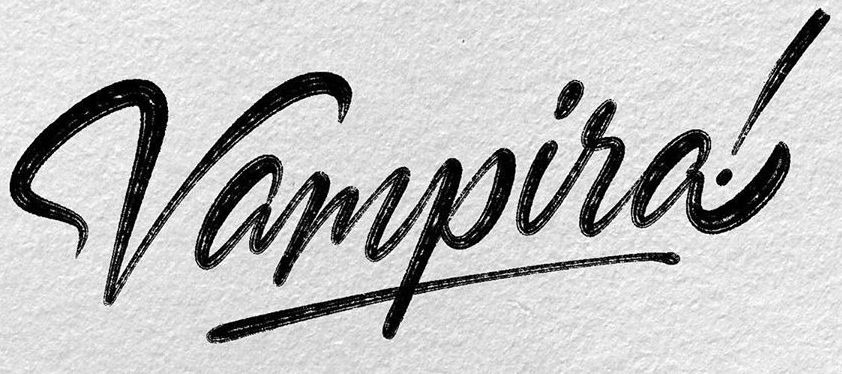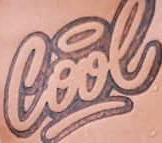What words can you see in these images in sequence, separated by a semicolon? Vampira!; Cool 